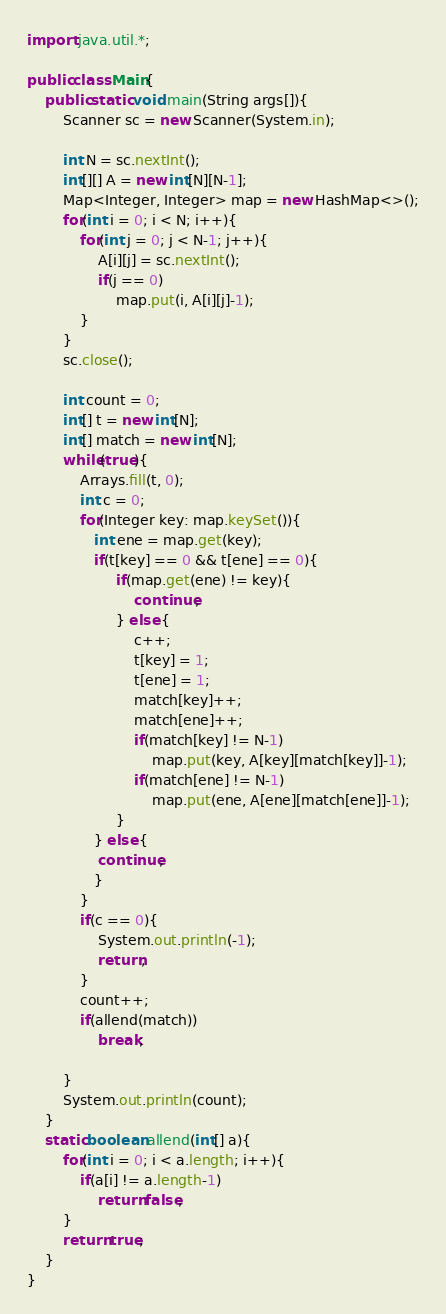<code> <loc_0><loc_0><loc_500><loc_500><_Java_>import java.util.*;

public class Main{
    public static void main(String args[]){
        Scanner sc = new Scanner(System.in);

        int N = sc.nextInt();
        int[][] A = new int[N][N-1];
        Map<Integer, Integer> map = new HashMap<>();
        for(int i = 0; i < N; i++){
            for(int j = 0; j < N-1; j++){
                A[i][j] = sc.nextInt();
                if(j == 0)
                    map.put(i, A[i][j]-1);
            }
        }
        sc.close();

        int count = 0;
        int[] t = new int[N];
        int[] match = new int[N];
        while(true){
            Arrays.fill(t, 0);
            int c = 0;
            for(Integer key: map.keySet()){
               int ene = map.get(key);
               if(t[key] == 0 && t[ene] == 0){
                    if(map.get(ene) != key){
                        continue;
                    } else {
                        c++;
                        t[key] = 1;
                        t[ene] = 1;
                        match[key]++;
                        match[ene]++;
                        if(match[key] != N-1)
                            map.put(key, A[key][match[key]]-1);
                        if(match[ene] != N-1)
                            map.put(ene, A[ene][match[ene]]-1);
                    }
               } else {
                continue;
               }
            }
            if(c == 0){
                System.out.println(-1);
                return;
            }
            count++;
            if(allend(match))
                break;
            
        }
        System.out.println(count);
    }
    static boolean allend(int[] a){
        for(int i = 0; i < a.length; i++){
            if(a[i] != a.length-1)
                return false;
        }
        return true;
    }
}</code> 